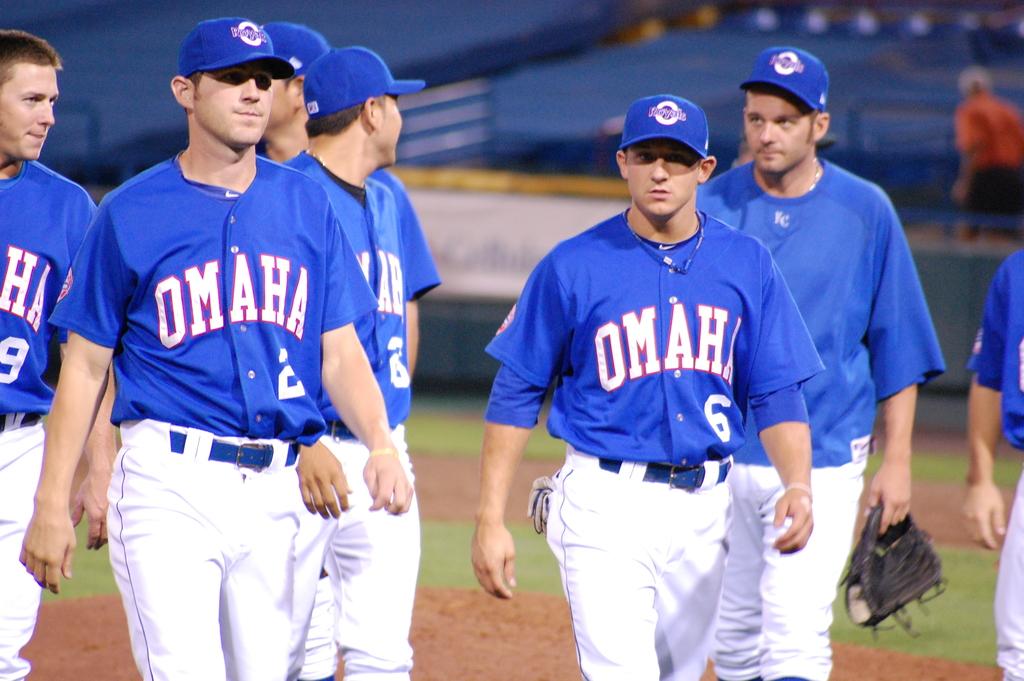What team is walking on the field?
Offer a very short reply. Omaha. What is the player number on the right?
Offer a terse response. 6. 